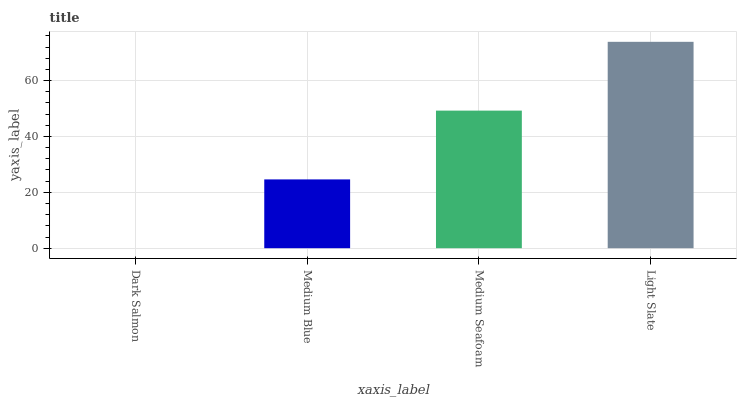Is Dark Salmon the minimum?
Answer yes or no. Yes. Is Light Slate the maximum?
Answer yes or no. Yes. Is Medium Blue the minimum?
Answer yes or no. No. Is Medium Blue the maximum?
Answer yes or no. No. Is Medium Blue greater than Dark Salmon?
Answer yes or no. Yes. Is Dark Salmon less than Medium Blue?
Answer yes or no. Yes. Is Dark Salmon greater than Medium Blue?
Answer yes or no. No. Is Medium Blue less than Dark Salmon?
Answer yes or no. No. Is Medium Seafoam the high median?
Answer yes or no. Yes. Is Medium Blue the low median?
Answer yes or no. Yes. Is Medium Blue the high median?
Answer yes or no. No. Is Dark Salmon the low median?
Answer yes or no. No. 